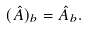<formula> <loc_0><loc_0><loc_500><loc_500>( \hat { A } ) _ { b } = \hat { A } _ { b } .</formula> 